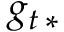Convert formula to latex. <formula><loc_0><loc_0><loc_500><loc_500>g _ { t \, * }</formula> 